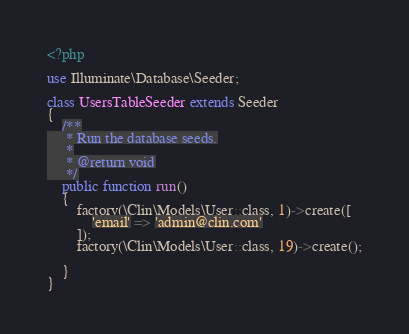<code> <loc_0><loc_0><loc_500><loc_500><_PHP_><?php

use Illuminate\Database\Seeder;

class UsersTableSeeder extends Seeder
{
    /**
     * Run the database seeds.
     *
     * @return void
     */
    public function run()
    {
        factory(\Clin\Models\User::class, 1)->create([
            'email' => 'admin@clin.com'
        ]);
        factory(\Clin\Models\User::class, 19)->create();

    }
}
</code> 